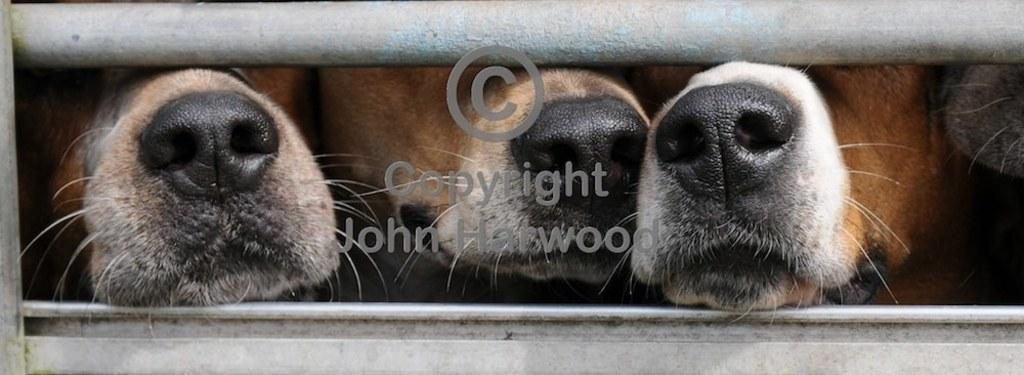What type of animals are present in the image? There are three crows and cows in the image. Can you describe the appearance of the crows? The faces of the crows are not visible in the image. What part of the cows' faces can be seen? The noses and mouths of the cows are visible in the image. What type of barrier is present in the image? There is a metal pole fence in the image. What color is the cherry that is being folded in the middle of the image? There is no cherry present in the image, nor is there any folding activity taking place. 